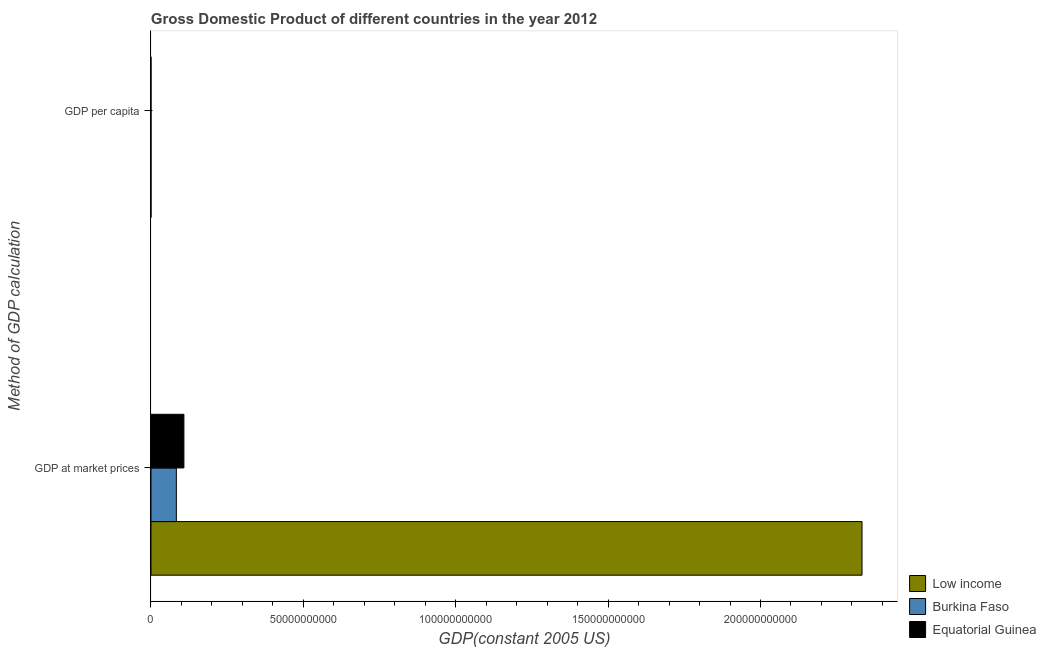Are the number of bars on each tick of the Y-axis equal?
Offer a terse response. Yes. How many bars are there on the 1st tick from the top?
Offer a terse response. 3. How many bars are there on the 1st tick from the bottom?
Your response must be concise. 3. What is the label of the 2nd group of bars from the top?
Your response must be concise. GDP at market prices. What is the gdp at market prices in Burkina Faso?
Your answer should be compact. 8.33e+09. Across all countries, what is the maximum gdp at market prices?
Offer a terse response. 2.33e+11. Across all countries, what is the minimum gdp per capita?
Give a very brief answer. 395.88. In which country was the gdp at market prices maximum?
Your response must be concise. Low income. What is the total gdp at market prices in the graph?
Your answer should be very brief. 2.52e+11. What is the difference between the gdp at market prices in Equatorial Guinea and that in Burkina Faso?
Keep it short and to the point. 2.48e+09. What is the difference between the gdp per capita in Equatorial Guinea and the gdp at market prices in Low income?
Offer a very short reply. -2.33e+11. What is the average gdp at market prices per country?
Offer a terse response. 8.42e+1. What is the difference between the gdp per capita and gdp at market prices in Low income?
Ensure brevity in your answer.  -2.33e+11. What is the ratio of the gdp at market prices in Burkina Faso to that in Equatorial Guinea?
Your response must be concise. 0.77. Is the gdp at market prices in Equatorial Guinea less than that in Low income?
Offer a very short reply. Yes. In how many countries, is the gdp per capita greater than the average gdp per capita taken over all countries?
Keep it short and to the point. 1. What does the 1st bar from the top in GDP at market prices represents?
Give a very brief answer. Equatorial Guinea. What does the 3rd bar from the bottom in GDP per capita represents?
Ensure brevity in your answer.  Equatorial Guinea. Are the values on the major ticks of X-axis written in scientific E-notation?
Your answer should be compact. No. Does the graph contain any zero values?
Your answer should be compact. No. Does the graph contain grids?
Offer a very short reply. No. How many legend labels are there?
Provide a short and direct response. 3. How are the legend labels stacked?
Make the answer very short. Vertical. What is the title of the graph?
Make the answer very short. Gross Domestic Product of different countries in the year 2012. What is the label or title of the X-axis?
Provide a short and direct response. GDP(constant 2005 US). What is the label or title of the Y-axis?
Give a very brief answer. Method of GDP calculation. What is the GDP(constant 2005 US) of Low income in GDP at market prices?
Provide a succinct answer. 2.33e+11. What is the GDP(constant 2005 US) in Burkina Faso in GDP at market prices?
Give a very brief answer. 8.33e+09. What is the GDP(constant 2005 US) of Equatorial Guinea in GDP at market prices?
Ensure brevity in your answer.  1.08e+1. What is the GDP(constant 2005 US) in Low income in GDP per capita?
Make the answer very short. 395.88. What is the GDP(constant 2005 US) of Burkina Faso in GDP per capita?
Offer a terse response. 502.15. What is the GDP(constant 2005 US) in Equatorial Guinea in GDP per capita?
Your response must be concise. 1.40e+04. Across all Method of GDP calculation, what is the maximum GDP(constant 2005 US) in Low income?
Provide a succinct answer. 2.33e+11. Across all Method of GDP calculation, what is the maximum GDP(constant 2005 US) in Burkina Faso?
Your answer should be very brief. 8.33e+09. Across all Method of GDP calculation, what is the maximum GDP(constant 2005 US) of Equatorial Guinea?
Provide a short and direct response. 1.08e+1. Across all Method of GDP calculation, what is the minimum GDP(constant 2005 US) in Low income?
Provide a succinct answer. 395.88. Across all Method of GDP calculation, what is the minimum GDP(constant 2005 US) in Burkina Faso?
Your answer should be compact. 502.15. Across all Method of GDP calculation, what is the minimum GDP(constant 2005 US) in Equatorial Guinea?
Your answer should be very brief. 1.40e+04. What is the total GDP(constant 2005 US) in Low income in the graph?
Ensure brevity in your answer.  2.33e+11. What is the total GDP(constant 2005 US) in Burkina Faso in the graph?
Your answer should be compact. 8.33e+09. What is the total GDP(constant 2005 US) in Equatorial Guinea in the graph?
Give a very brief answer. 1.08e+1. What is the difference between the GDP(constant 2005 US) of Low income in GDP at market prices and that in GDP per capita?
Your response must be concise. 2.33e+11. What is the difference between the GDP(constant 2005 US) in Burkina Faso in GDP at market prices and that in GDP per capita?
Offer a very short reply. 8.33e+09. What is the difference between the GDP(constant 2005 US) of Equatorial Guinea in GDP at market prices and that in GDP per capita?
Provide a succinct answer. 1.08e+1. What is the difference between the GDP(constant 2005 US) of Low income in GDP at market prices and the GDP(constant 2005 US) of Burkina Faso in GDP per capita?
Keep it short and to the point. 2.33e+11. What is the difference between the GDP(constant 2005 US) of Low income in GDP at market prices and the GDP(constant 2005 US) of Equatorial Guinea in GDP per capita?
Give a very brief answer. 2.33e+11. What is the difference between the GDP(constant 2005 US) in Burkina Faso in GDP at market prices and the GDP(constant 2005 US) in Equatorial Guinea in GDP per capita?
Offer a terse response. 8.33e+09. What is the average GDP(constant 2005 US) of Low income per Method of GDP calculation?
Offer a terse response. 1.17e+11. What is the average GDP(constant 2005 US) in Burkina Faso per Method of GDP calculation?
Keep it short and to the point. 4.17e+09. What is the average GDP(constant 2005 US) of Equatorial Guinea per Method of GDP calculation?
Provide a succinct answer. 5.40e+09. What is the difference between the GDP(constant 2005 US) of Low income and GDP(constant 2005 US) of Burkina Faso in GDP at market prices?
Give a very brief answer. 2.25e+11. What is the difference between the GDP(constant 2005 US) of Low income and GDP(constant 2005 US) of Equatorial Guinea in GDP at market prices?
Your answer should be compact. 2.23e+11. What is the difference between the GDP(constant 2005 US) in Burkina Faso and GDP(constant 2005 US) in Equatorial Guinea in GDP at market prices?
Your response must be concise. -2.48e+09. What is the difference between the GDP(constant 2005 US) in Low income and GDP(constant 2005 US) in Burkina Faso in GDP per capita?
Your answer should be compact. -106.27. What is the difference between the GDP(constant 2005 US) of Low income and GDP(constant 2005 US) of Equatorial Guinea in GDP per capita?
Your answer should be compact. -1.36e+04. What is the difference between the GDP(constant 2005 US) of Burkina Faso and GDP(constant 2005 US) of Equatorial Guinea in GDP per capita?
Your answer should be very brief. -1.35e+04. What is the ratio of the GDP(constant 2005 US) in Low income in GDP at market prices to that in GDP per capita?
Offer a very short reply. 5.89e+08. What is the ratio of the GDP(constant 2005 US) of Burkina Faso in GDP at market prices to that in GDP per capita?
Provide a succinct answer. 1.66e+07. What is the ratio of the GDP(constant 2005 US) in Equatorial Guinea in GDP at market prices to that in GDP per capita?
Provide a short and direct response. 7.74e+05. What is the difference between the highest and the second highest GDP(constant 2005 US) in Low income?
Provide a short and direct response. 2.33e+11. What is the difference between the highest and the second highest GDP(constant 2005 US) in Burkina Faso?
Offer a terse response. 8.33e+09. What is the difference between the highest and the second highest GDP(constant 2005 US) in Equatorial Guinea?
Provide a short and direct response. 1.08e+1. What is the difference between the highest and the lowest GDP(constant 2005 US) in Low income?
Your response must be concise. 2.33e+11. What is the difference between the highest and the lowest GDP(constant 2005 US) of Burkina Faso?
Make the answer very short. 8.33e+09. What is the difference between the highest and the lowest GDP(constant 2005 US) in Equatorial Guinea?
Your response must be concise. 1.08e+1. 